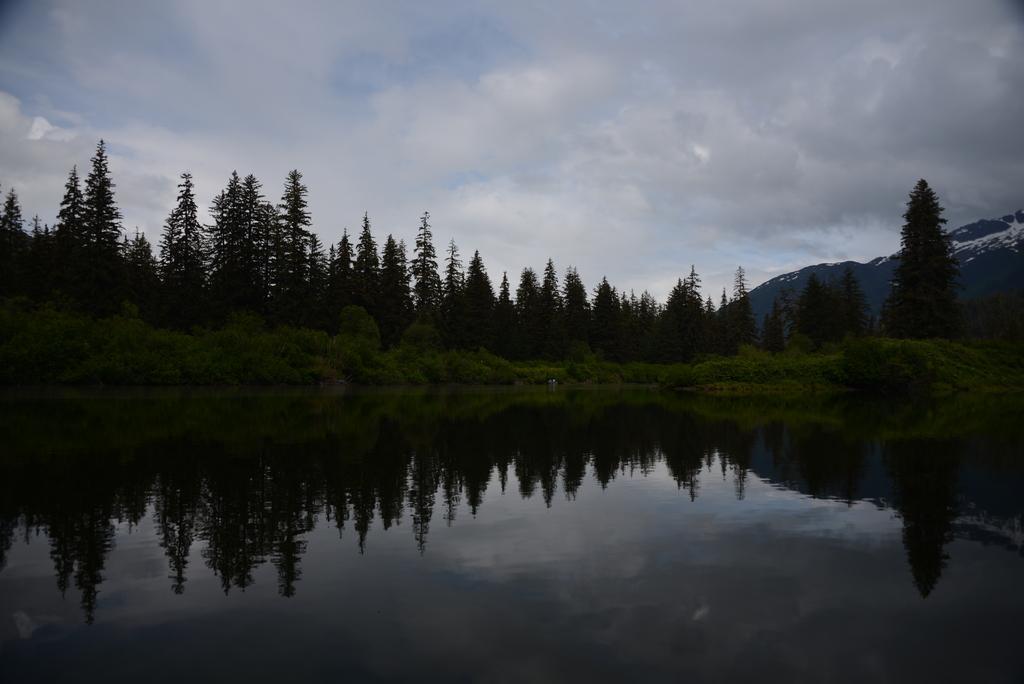In one or two sentences, can you explain what this image depicts? In this image I can see the water. In the background, I can see the trees, hills and clouds in the sky. 